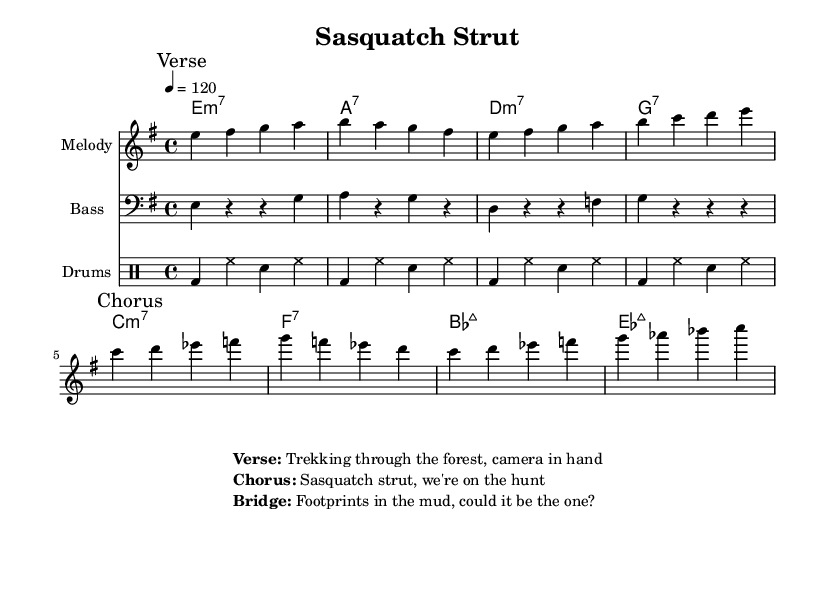What is the key signature of this music? The key signature is indicated by the "e" in the key signature section, which shows that the piece is in e minor. This is derived from the overall key declaration.
Answer: e minor What is the time signature of this piece? The time signature is represented as "4/4" in the music, which means there are four beats in each measure and the quarter note gets one beat. This is stated clearly at the beginning of the score.
Answer: 4/4 What is the tempo marking for this piece? The tempo marking is indicated by "4 = 120," meaning there are 120 beats per minute in the tempo of the piece. This is found near the top where the global instructions are provided.
Answer: 120 What is the first note of the melody? The first note of the melody is found at the beginning of the melody staff, and it is "e". This is the first note written after the global directives.
Answer: e What chord follows the first bar in the chorus? The chord that follows the first bar in the chorus is the a7 chord, as indicated by the chord progression right after the first section. It appears in the chord names under the melody.
Answer: a7 What is the main theme of the lyrics in the chorus? The main theme of the lyrics in the chorus, as noted, involves the excitement of the hunt for sasquatch, which reflects a sense of adventure and exploration. It is specifically highlighted in the chorus section where the words are placed.
Answer: Sasquatch strut How many measures are in the melody before the first break? The melody contains four measures before the first break, which can be counted in the melody section. Each measure is separated by a vertical line, and counting those gives a total of four before the break is indicated.
Answer: 4 